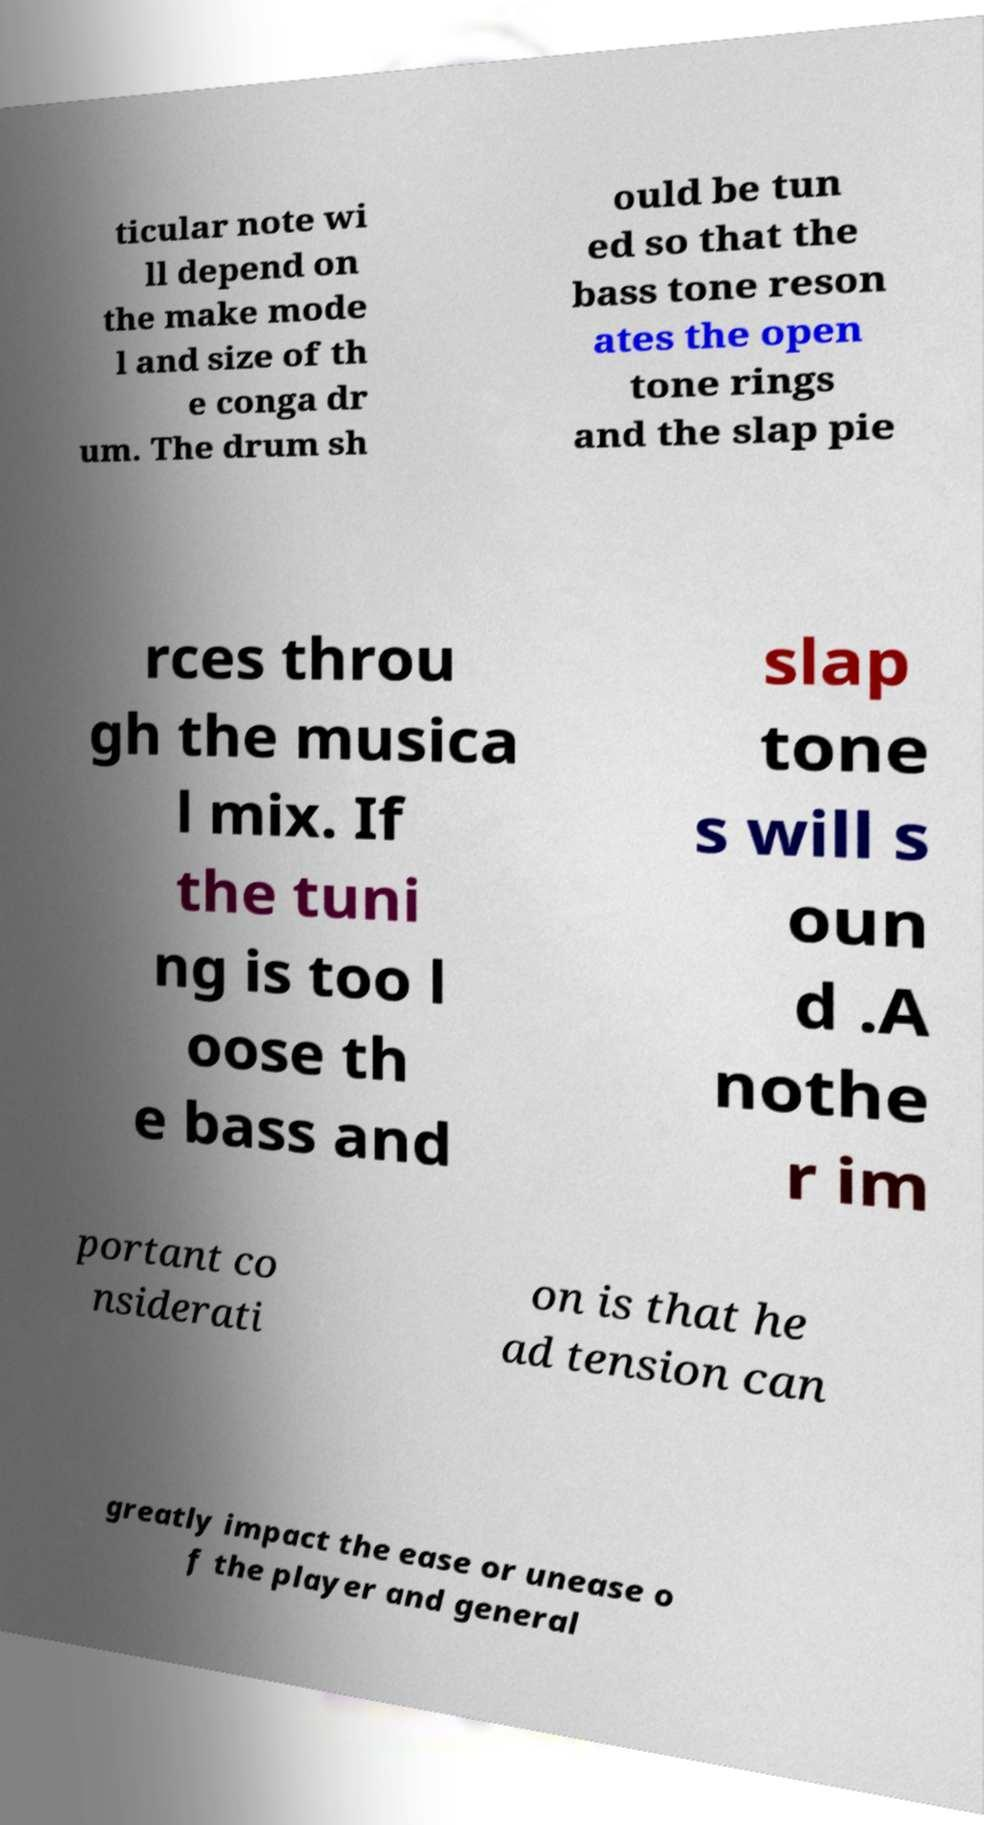I need the written content from this picture converted into text. Can you do that? ticular note wi ll depend on the make mode l and size of th e conga dr um. The drum sh ould be tun ed so that the bass tone reson ates the open tone rings and the slap pie rces throu gh the musica l mix. If the tuni ng is too l oose th e bass and slap tone s will s oun d .A nothe r im portant co nsiderati on is that he ad tension can greatly impact the ease or unease o f the player and general 